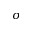Convert formula to latex. <formula><loc_0><loc_0><loc_500><loc_500>\sigma</formula> 